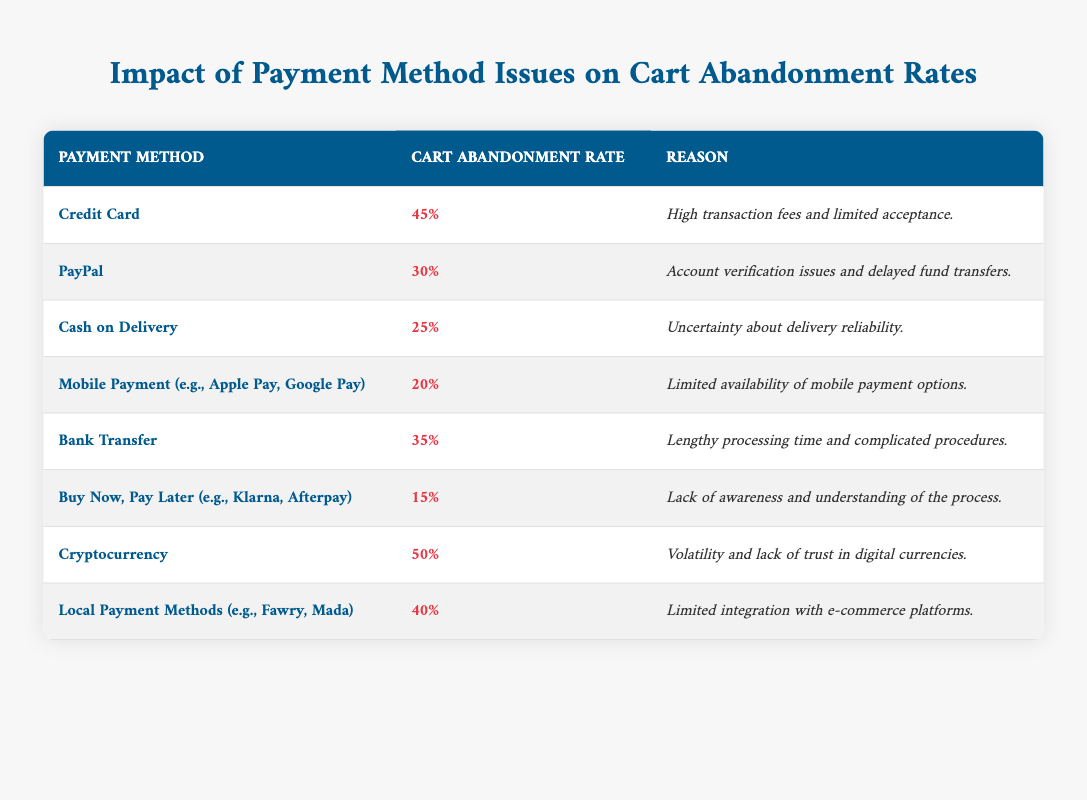What is the highest cart abandonment rate among the payment methods? The table shows that the payment method with the highest cart abandonment rate is Cryptocurrency at 50%.
Answer: 50% Which payment method has the lowest cart abandonment rate? The payment method with the lowest cart abandonment rate is Buy Now, Pay Later at 15%.
Answer: 15% What is the cart abandonment rate for Cash on Delivery? Referring to the table, Cash on Delivery has a cart abandonment rate of 25%.
Answer: 25% How many payment methods have a cart abandonment rate of 40% or higher? The following methods have rates of 40% or higher: Credit Card (45%), Cryptocurrency (50%), and Local Payment Methods (40%). This means there are 3 such payment methods.
Answer: 3 What is the average cart abandonment rate of all payment methods listed? To find the average, we sum the abandonment rates: (45 + 30 + 25 + 20 + 35 + 15 + 50 + 40) = 250. There are 8 methods, so the average is 250 / 8 = 31.25%.
Answer: 31.25% Is it true that Cash on Delivery has a lower abandonment rate than PayPal? The table shows Cash on Delivery at 25% and PayPal at 30%. Therefore, Cash on Delivery does have a lower rate than PayPal.
Answer: Yes Which methods have issues related to integration or acceptance? Credit Card, Local Payment Methods, and Bank Transfer have issues related to acceptance or integration as indicated by their respective reasons provided in the table.
Answer: Credit Card, Local Payment Methods, Bank Transfer What is the difference between the highest and lowest abandonment rates? The highest is 50% for Cryptocurrency and the lowest is 15% for Buy Now, Pay Later. The difference is 50% - 15% = 35%.
Answer: 35% Which payment method has the same percentage of abandoned carts as Local Payment Methods? Local Payment Methods have an abandonment rate of 40%, but no other method matches it in this table.
Answer: None Can we conclude that all payment methods listed have an abandonment rate over 15%? The lowest abandonment rate mentioned is 15% for Buy Now, Pay Later; all other methods are higher. Therefore, we can conclude that yes, all payment methods have rates over 15%.
Answer: Yes 